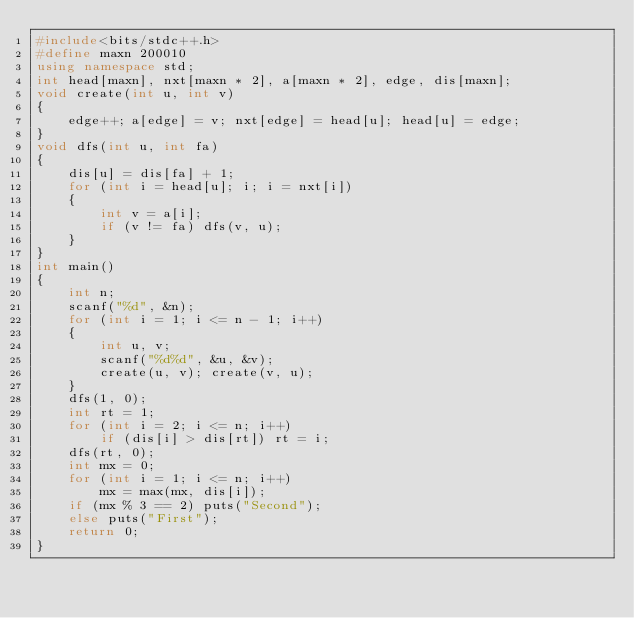<code> <loc_0><loc_0><loc_500><loc_500><_C++_>#include<bits/stdc++.h>
#define maxn 200010
using namespace std;
int head[maxn], nxt[maxn * 2], a[maxn * 2], edge, dis[maxn];
void create(int u, int v)
{
	edge++; a[edge] = v; nxt[edge] = head[u]; head[u] = edge;
}
void dfs(int u, int fa)
{
	dis[u] = dis[fa] + 1;
	for (int i = head[u]; i; i = nxt[i])
	{
		int v = a[i];
		if (v != fa) dfs(v, u);
	}
}
int main()
{
	int n;
	scanf("%d", &n);
	for (int i = 1; i <= n - 1; i++)
	{
		int u, v;
		scanf("%d%d", &u, &v);
		create(u, v); create(v, u);
	}
	dfs(1, 0);
	int rt = 1;
	for (int i = 2; i <= n; i++)
		if (dis[i] > dis[rt]) rt = i;
	dfs(rt, 0);
	int mx = 0;
	for (int i = 1; i <= n; i++)
		mx = max(mx, dis[i]);
	if (mx % 3 == 2) puts("Second");
	else puts("First");
	return 0;
}</code> 